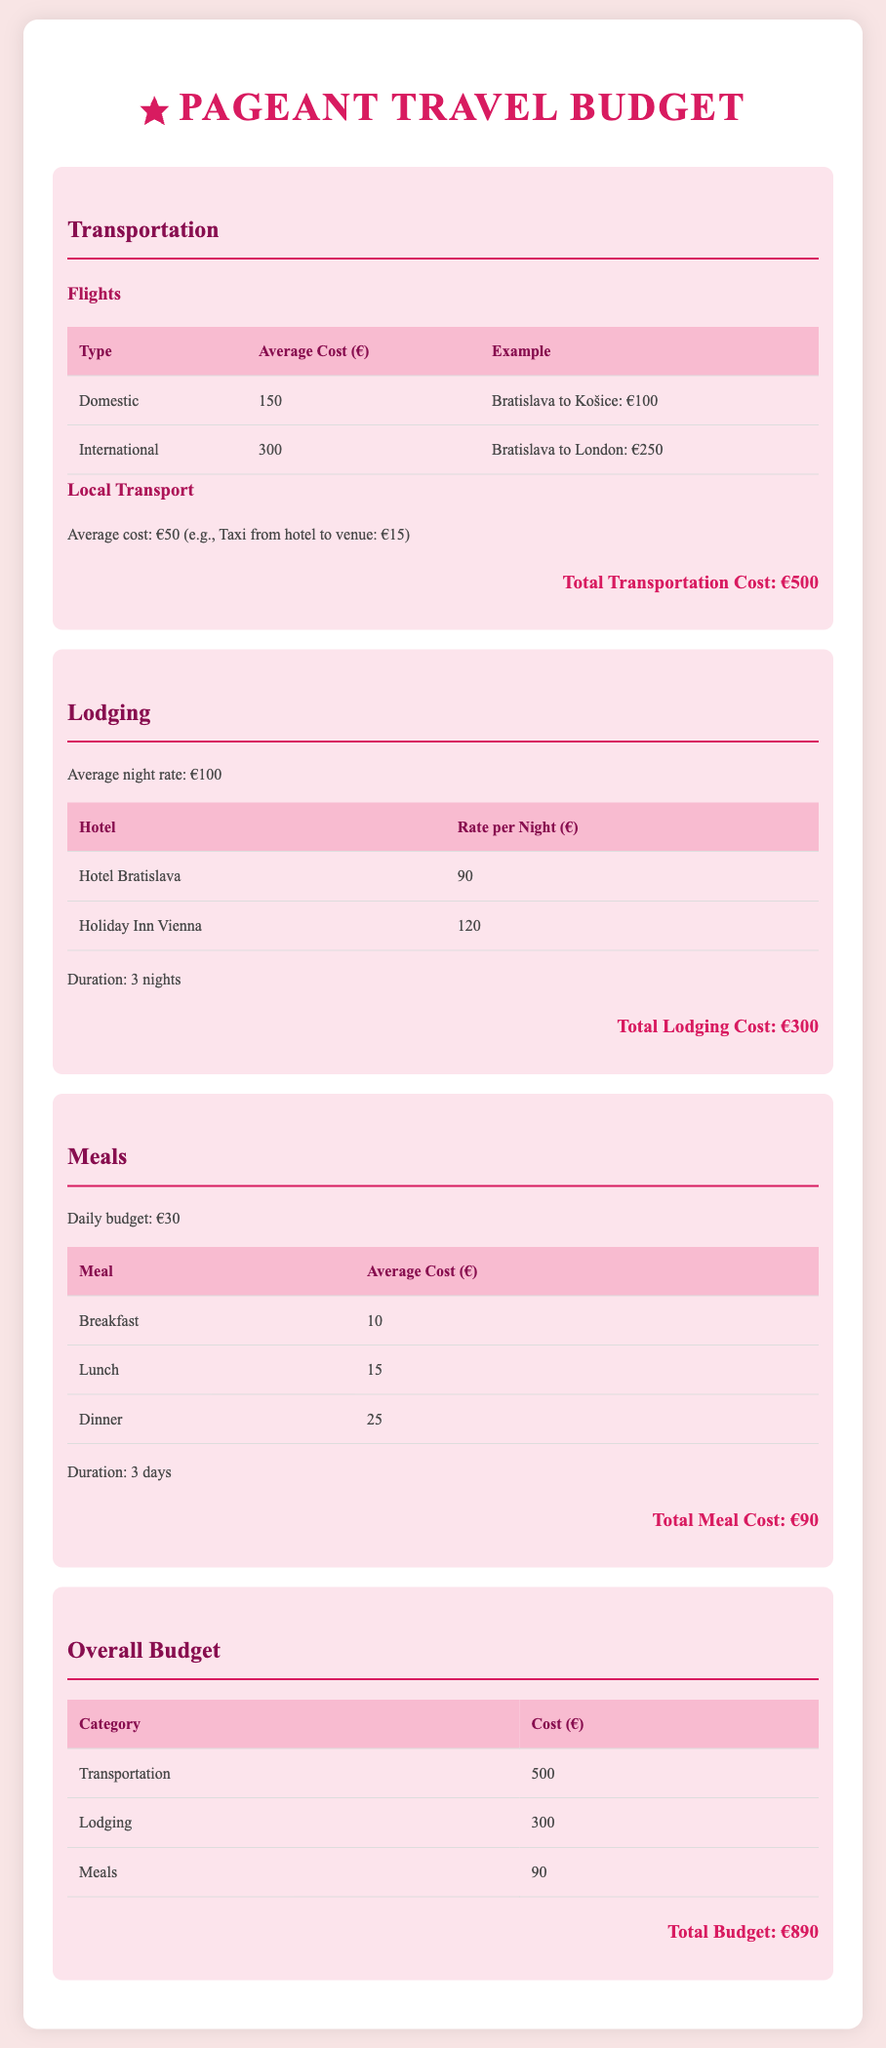What is the average cost of domestic flights? The average cost of domestic flights is listed in the transportation section of the document.
Answer: 150 What is the rate per night for Hotel Bratislava? The rate per night for Hotel Bratislava is provided in the lodging section of the document.
Answer: 90 How much is the total lodging cost? The total lodging cost is calculated based on the duration and nightly rate in the lodging section.
Answer: 300 What is the daily budget for meals? The daily budget for meals is mentioned in the meals section of the document.
Answer: 30 What is the average cost of breakfast? The average cost of breakfast is specified in the meals section of the document.
Answer: 10 What is the total transportation cost? The total transportation cost is the sum of the flight and local transport costs outlined in the transportation section.
Answer: 500 How many nights will the lodging be for? The duration of lodging is explicitly mentioned in the lodging section of the document.
Answer: 3 What is the total budget for the trip? The total budget is a summation of all expenses detailed in the overall budget section.
Answer: 890 What is the total meal cost? The total meal cost is calculated based on the duration and daily meal budget in the meals section.
Answer: 90 